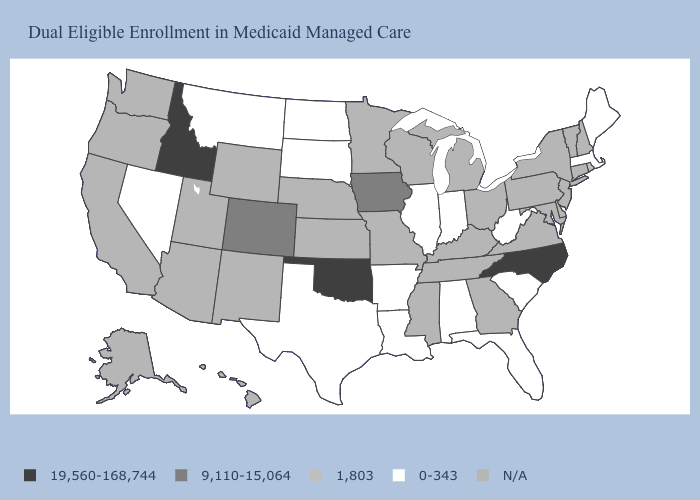Name the states that have a value in the range 9,110-15,064?
Write a very short answer. Colorado, Iowa. Among the states that border Ohio , which have the highest value?
Write a very short answer. Indiana, West Virginia. Name the states that have a value in the range 1,803?
Quick response, please. Rhode Island. Name the states that have a value in the range 0-343?
Answer briefly. Alabama, Arkansas, Florida, Illinois, Indiana, Louisiana, Maine, Massachusetts, Montana, Nevada, North Dakota, South Carolina, South Dakota, Texas, West Virginia. What is the value of Washington?
Give a very brief answer. N/A. What is the highest value in the MidWest ?
Quick response, please. 9,110-15,064. Does Oklahoma have the highest value in the South?
Be succinct. Yes. Name the states that have a value in the range 19,560-168,744?
Give a very brief answer. Idaho, North Carolina, Oklahoma. Does the first symbol in the legend represent the smallest category?
Give a very brief answer. No. Which states have the lowest value in the West?
Concise answer only. Montana, Nevada. Which states hav the highest value in the West?
Answer briefly. Idaho. What is the value of Mississippi?
Concise answer only. N/A. Name the states that have a value in the range 1,803?
Give a very brief answer. Rhode Island. Does Alabama have the lowest value in the South?
Be succinct. Yes. Does the first symbol in the legend represent the smallest category?
Quick response, please. No. 